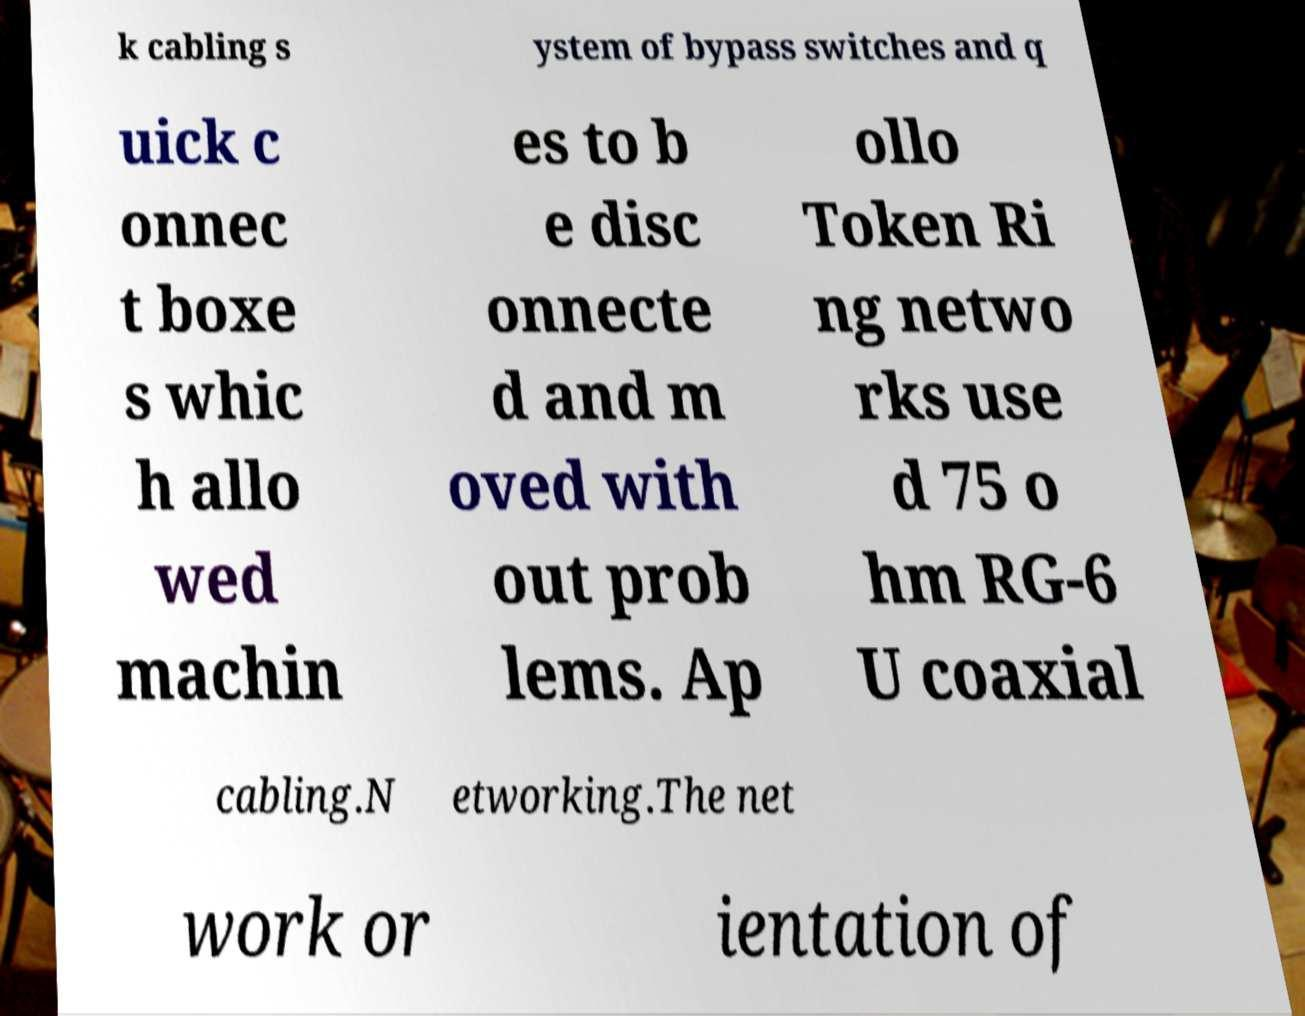There's text embedded in this image that I need extracted. Can you transcribe it verbatim? k cabling s ystem of bypass switches and q uick c onnec t boxe s whic h allo wed machin es to b e disc onnecte d and m oved with out prob lems. Ap ollo Token Ri ng netwo rks use d 75 o hm RG-6 U coaxial cabling.N etworking.The net work or ientation of 